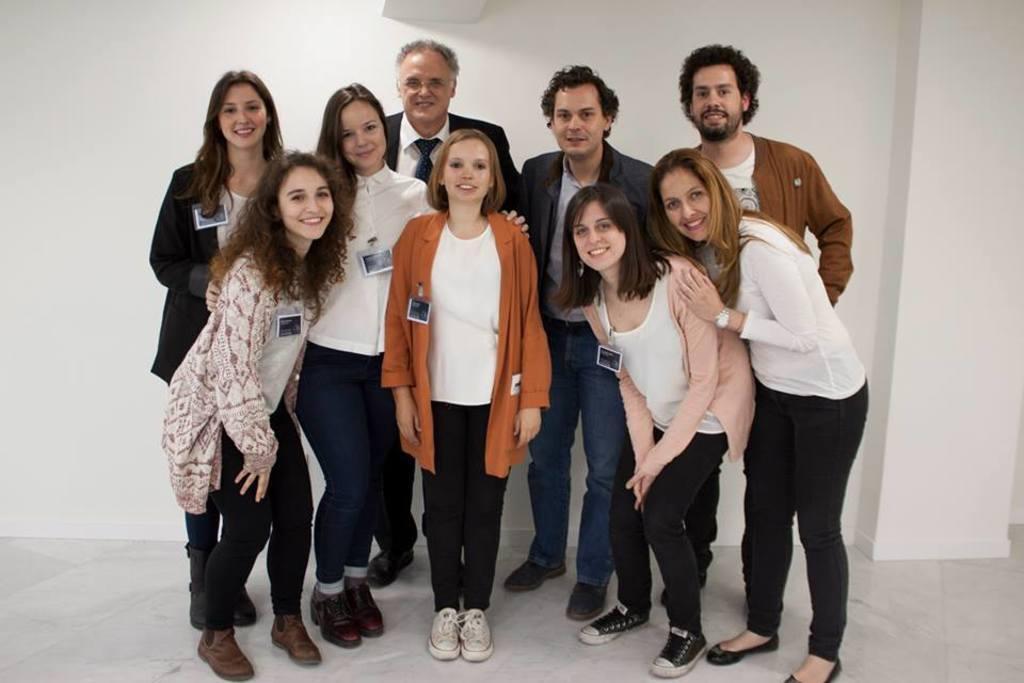How would you summarize this image in a sentence or two? In this image I see number of people who are standing and I see that all of them are smiling and I see the floor. In the background I see the white wall. 